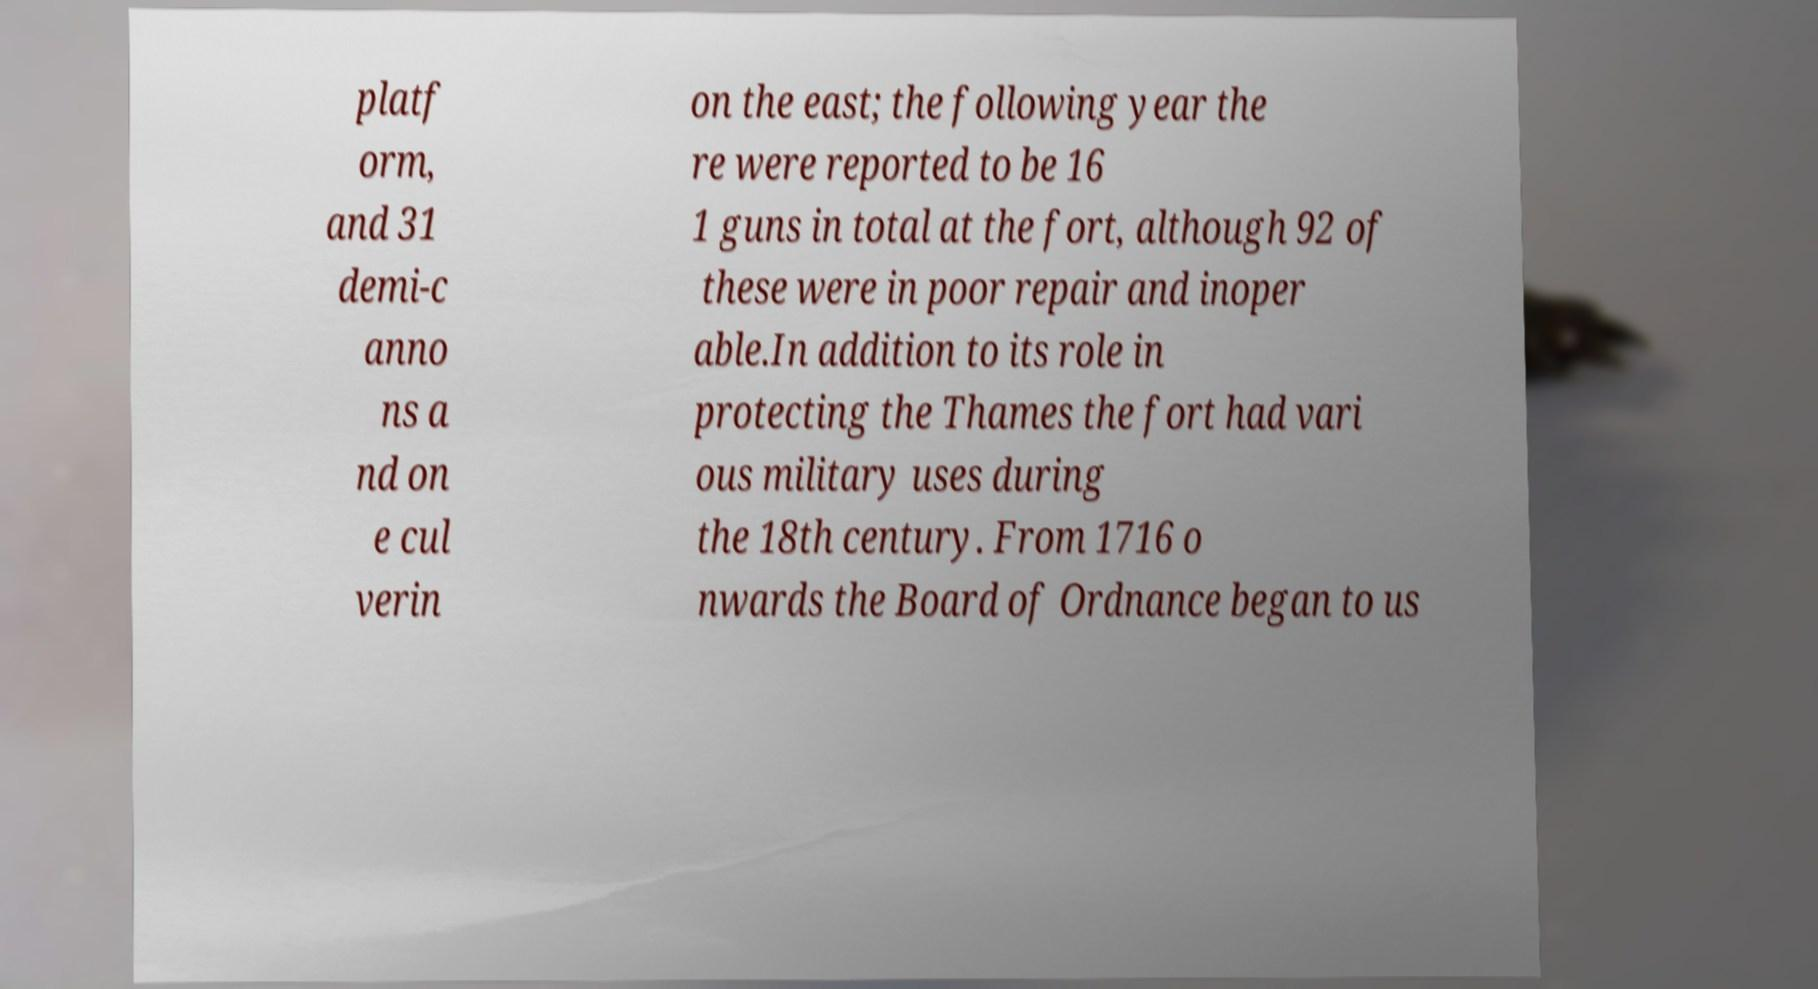Could you extract and type out the text from this image? platf orm, and 31 demi-c anno ns a nd on e cul verin on the east; the following year the re were reported to be 16 1 guns in total at the fort, although 92 of these were in poor repair and inoper able.In addition to its role in protecting the Thames the fort had vari ous military uses during the 18th century. From 1716 o nwards the Board of Ordnance began to us 